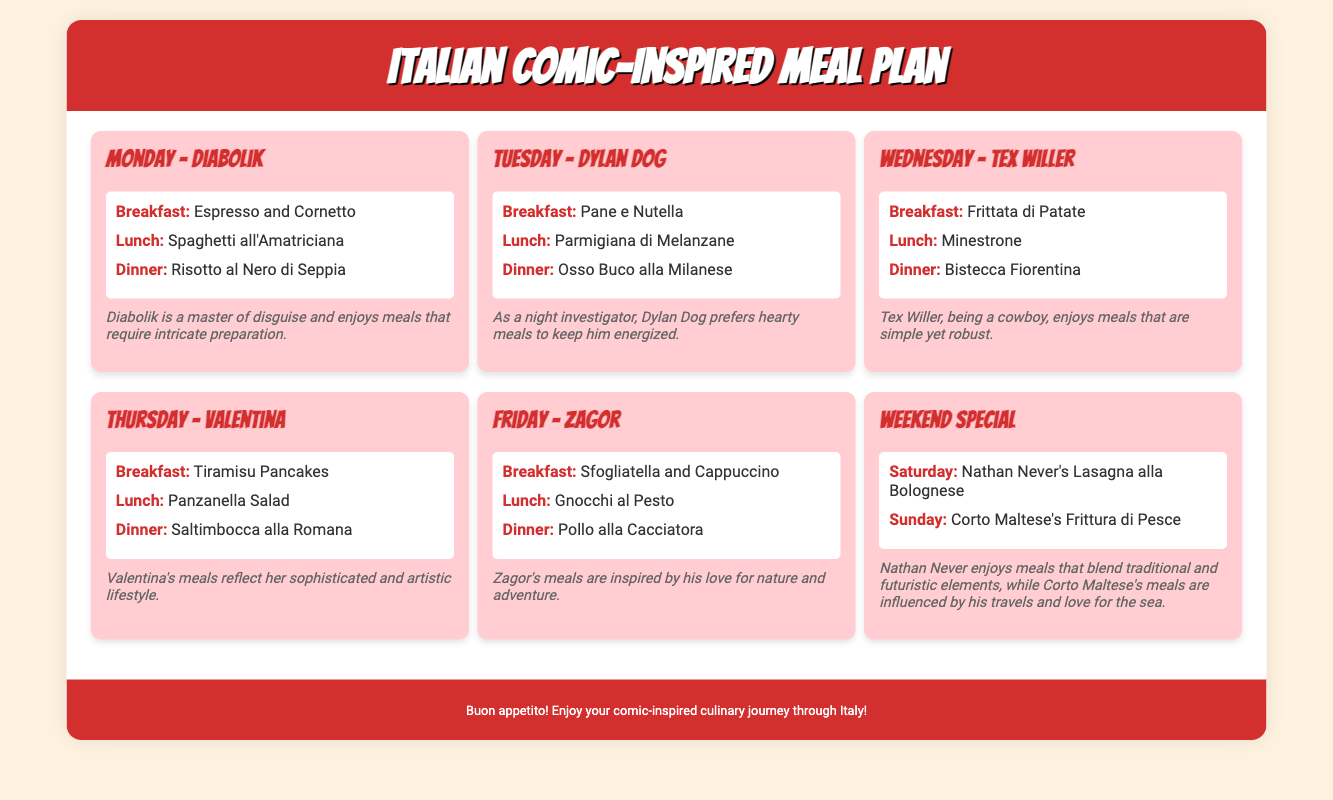What is the theme of the meal plan? The meal plan is inspired by popular Italian comic book characters, featuring meals themed around them.
Answer: Italian comic characters Which character is associated with Monday's meals? The document clearly states that Monday's meals are themed around the character Diabolik.
Answer: Diabolik What is the dinner suggestion for Tuesday? By reviewing the meals listed for Tuesday, the dinner suggestion is Osso Buco alla Milanese.
Answer: Osso Buco alla Milanese What type of cuisine does Zagor's meals reflect? Zagor's meals are influenced by his love for nature and adventure, representing simple yet robust dishes.
Answer: Nature and adventure What is unique about the weekend special meals? The weekend special meals focus on characters Nathan Never and Corto Maltese, showcasing lasagna and fish respectively.
Answer: Nathan Never's Lasagna and Corto Maltese's Frittura di Pesce 